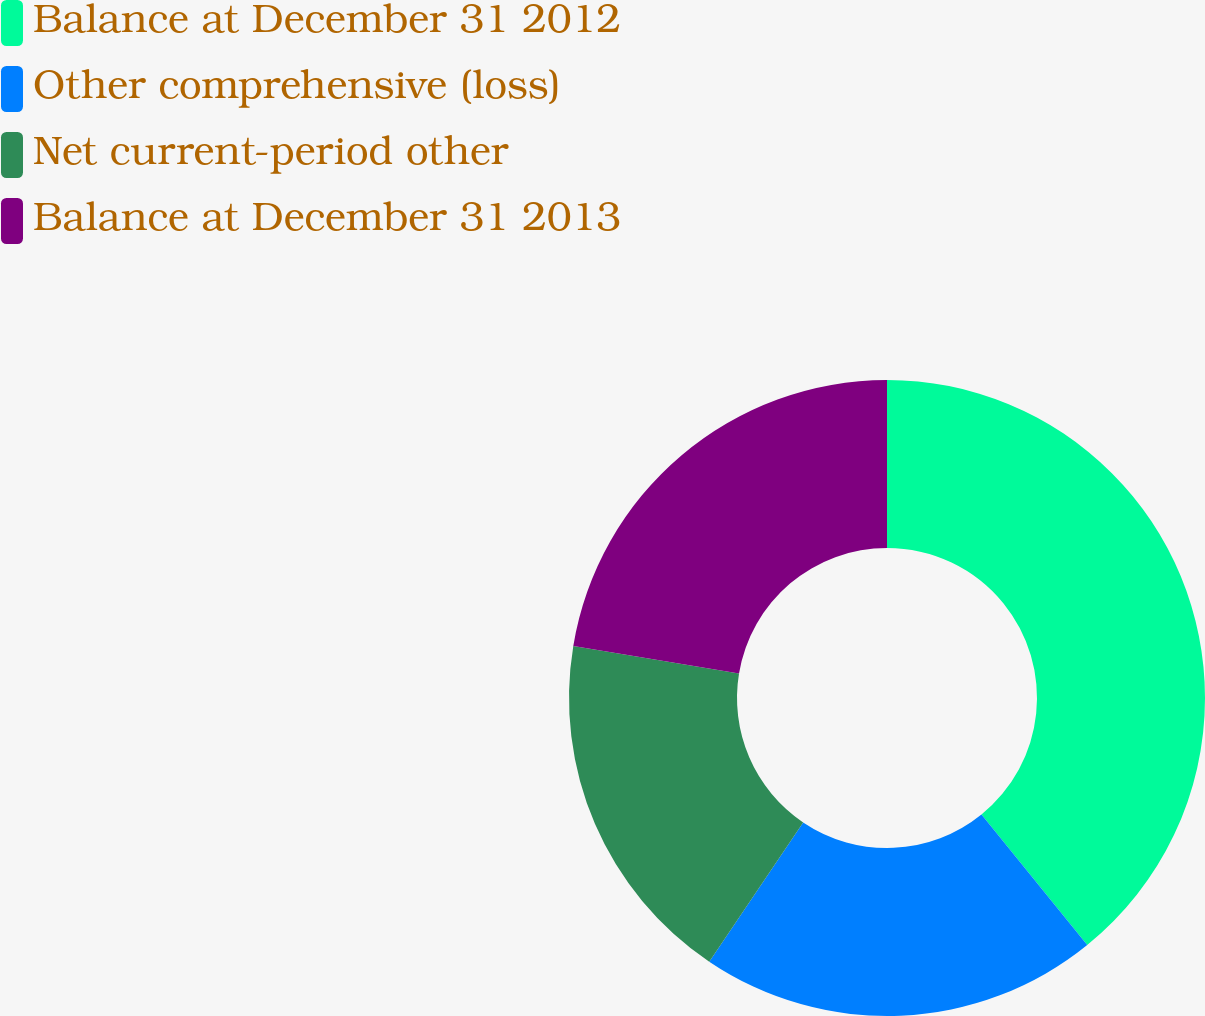<chart> <loc_0><loc_0><loc_500><loc_500><pie_chart><fcel>Balance at December 31 2012<fcel>Other comprehensive (loss)<fcel>Net current-period other<fcel>Balance at December 31 2013<nl><fcel>39.16%<fcel>20.28%<fcel>18.18%<fcel>22.38%<nl></chart> 